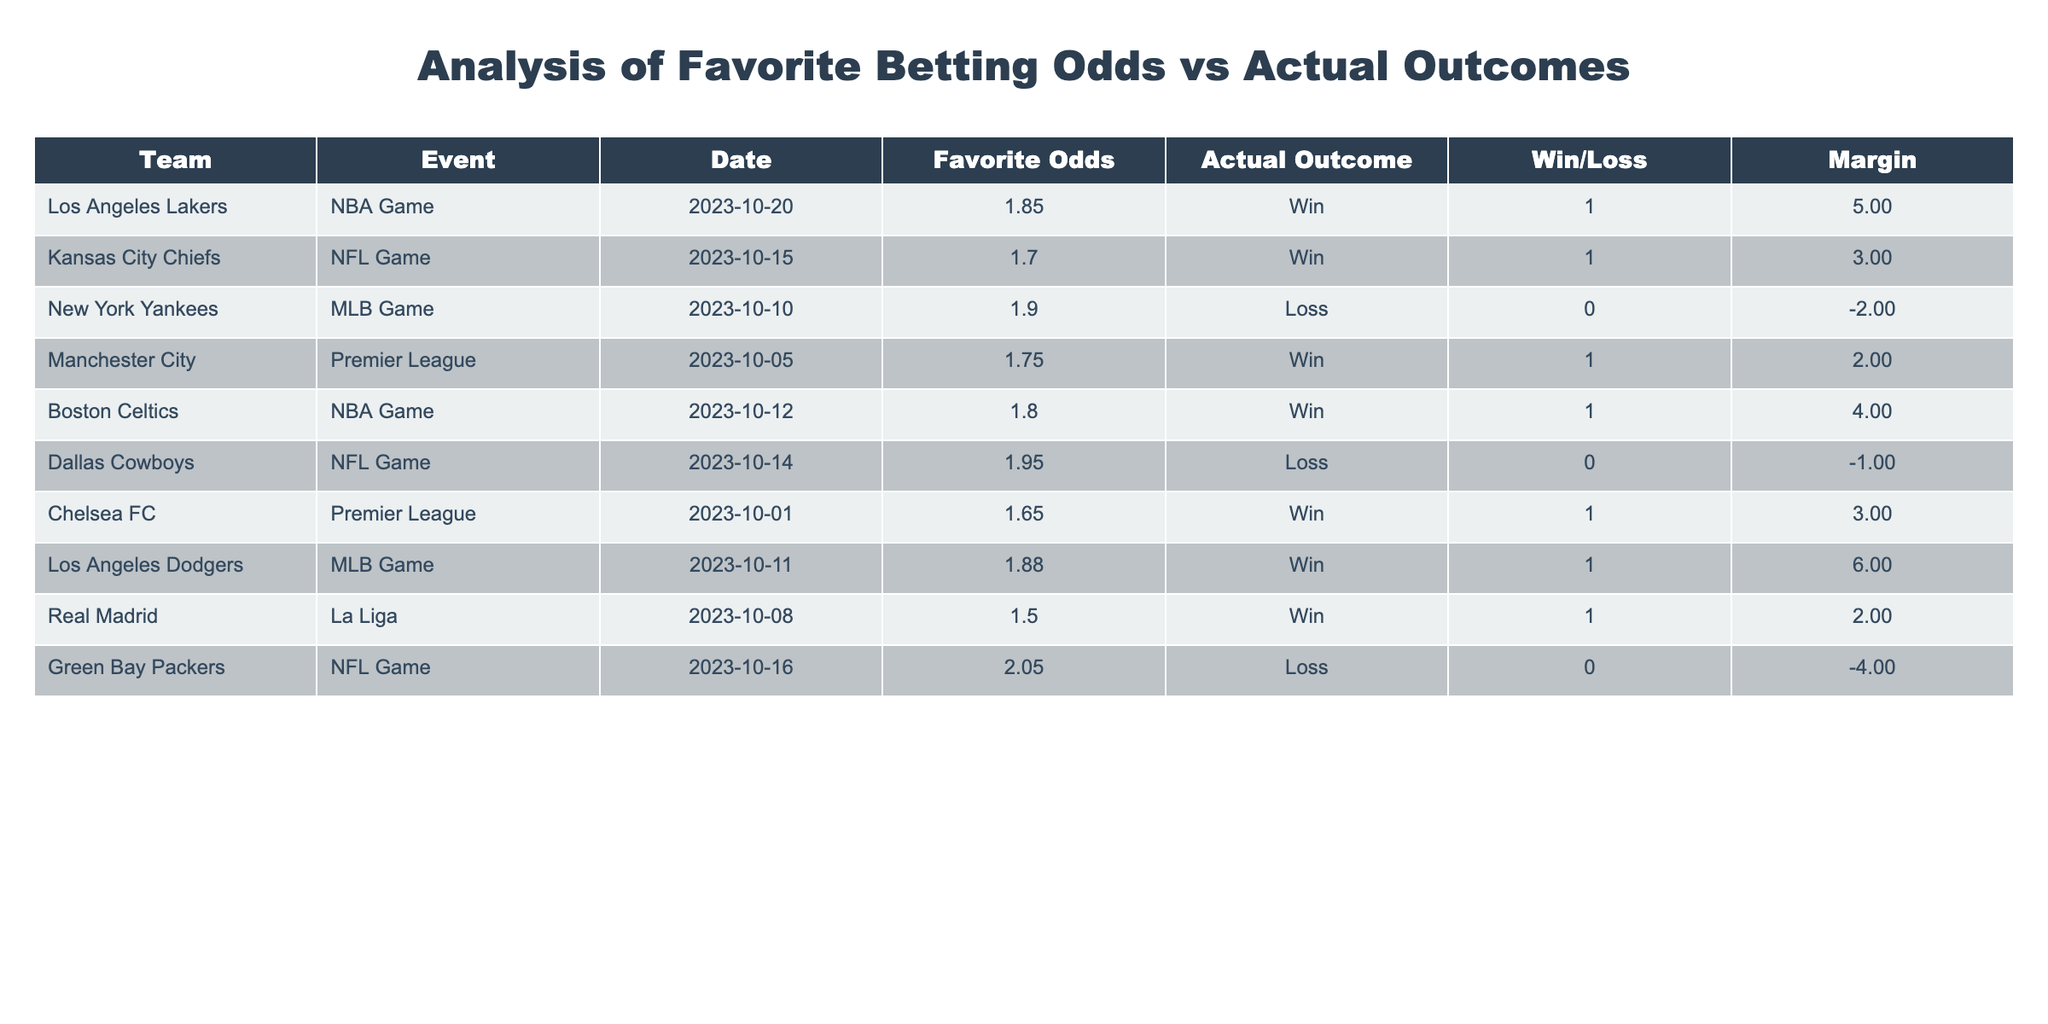What percentage of the favorites won their matches? There are 10 teams listed, and 7 of them won their matches. To find the percentage of winning favorites, we calculate (7 wins / 10 total) * 100 = 70%.
Answer: 70% Which team had the highest favorite odds and what was the outcome? The Dallas Cowboys had the highest favorite odds of 1.95, and they lost their match.
Answer: Dallas Cowboys, Loss Did the Los Angeles Lakers win their match? The table indicates that the Los Angeles Lakers won their match, as their actual outcome shows "Win".
Answer: Yes What is the average margin of victory for the winning favorites? There are 7 winning favorites with margins of 5, 3, 4, 2, 3, 6, and 2. First, sum these margins: 5 + 3 + 4 + 2 + 3 + 6 + 2 = 25. Then, divide by the 7 wins: 25 / 7 = approximately 3.57.
Answer: 3.57 How many favorites lost their matches by a margin of more than 2? From the table, the favorites that lost are the New York Yankees (margin -2), Dallas Cowboys (margin -1), and Green Bay Packers (margin -4). Only the Green Bay Packers lost by a margin greater than 2.
Answer: 1 